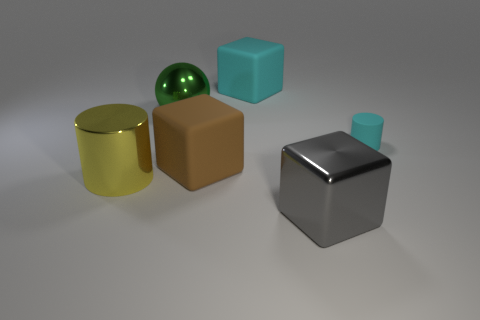Add 2 cyan shiny blocks. How many objects exist? 8 Subtract all spheres. How many objects are left? 5 Subtract all large cyan matte cylinders. Subtract all brown matte objects. How many objects are left? 5 Add 3 cyan cubes. How many cyan cubes are left? 4 Add 6 tiny gray matte cylinders. How many tiny gray matte cylinders exist? 6 Subtract 0 brown spheres. How many objects are left? 6 